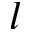Convert formula to latex. <formula><loc_0><loc_0><loc_500><loc_500>l</formula> 